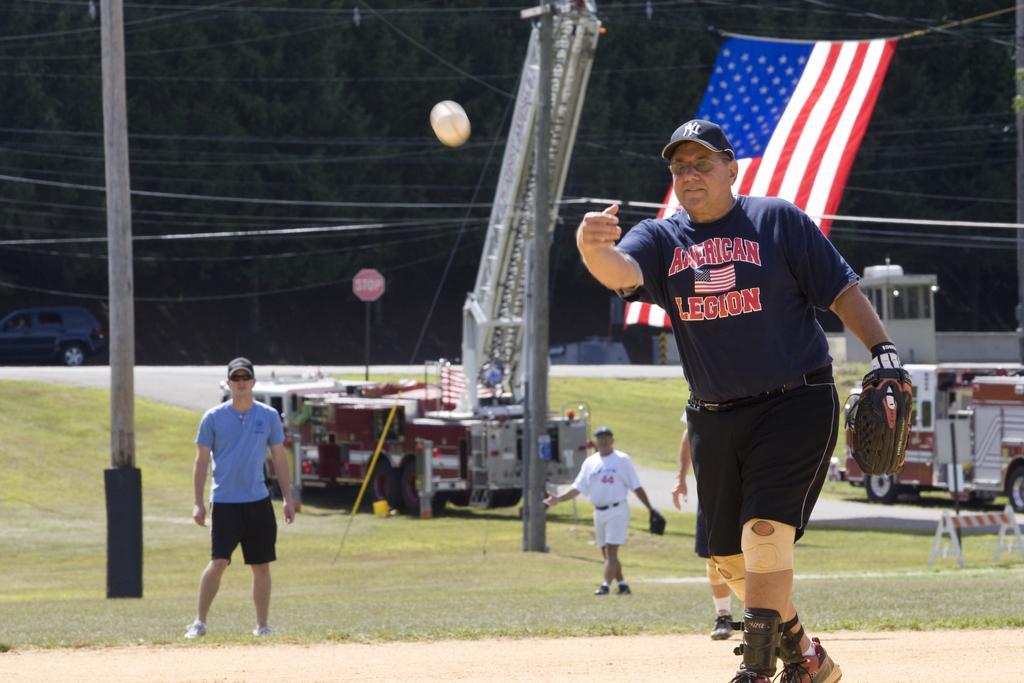In one or two sentences, can you explain what this image depicts? In this image there a few men standing. The man in the foreground is wearing catcher gloves. In front of him there is a ball in the air. There is grass on the ground. Behind them there are vehicles and poles. In the background there is a car on the road. Behind the car there are trees. To the right there is a flag. 